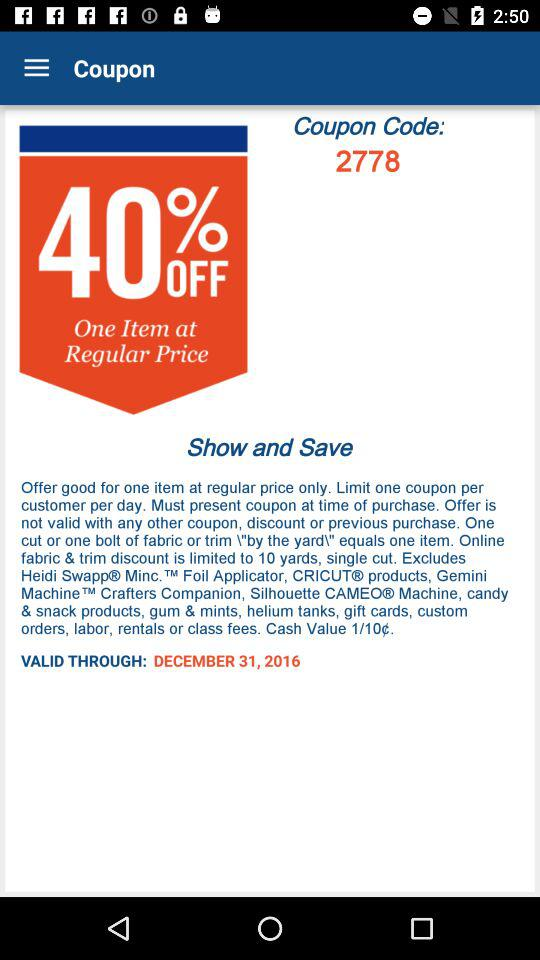What is the expiration date of this coupon?
Answer the question using a single word or phrase. December 31, 2016 